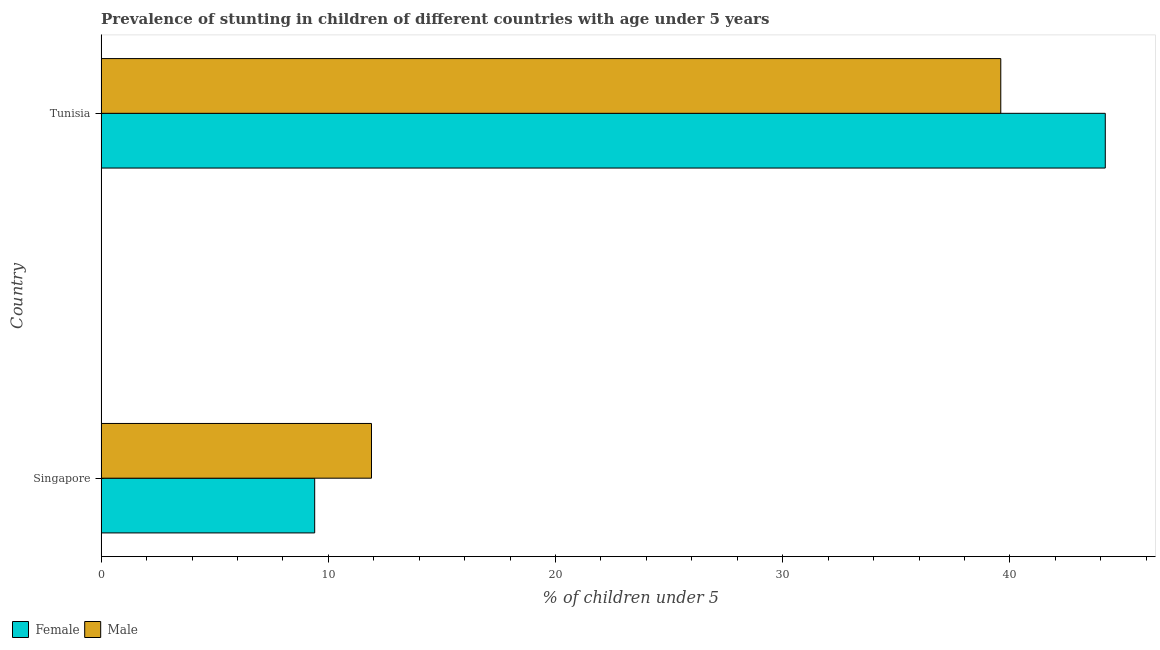Are the number of bars per tick equal to the number of legend labels?
Offer a very short reply. Yes. What is the label of the 1st group of bars from the top?
Keep it short and to the point. Tunisia. In how many cases, is the number of bars for a given country not equal to the number of legend labels?
Offer a terse response. 0. What is the percentage of stunted male children in Singapore?
Give a very brief answer. 11.9. Across all countries, what is the maximum percentage of stunted male children?
Ensure brevity in your answer.  39.6. Across all countries, what is the minimum percentage of stunted male children?
Give a very brief answer. 11.9. In which country was the percentage of stunted female children maximum?
Ensure brevity in your answer.  Tunisia. In which country was the percentage of stunted female children minimum?
Ensure brevity in your answer.  Singapore. What is the total percentage of stunted female children in the graph?
Provide a succinct answer. 53.6. What is the difference between the percentage of stunted female children in Singapore and that in Tunisia?
Your answer should be compact. -34.8. What is the difference between the percentage of stunted female children in Singapore and the percentage of stunted male children in Tunisia?
Provide a short and direct response. -30.2. What is the average percentage of stunted female children per country?
Give a very brief answer. 26.8. What is the difference between the percentage of stunted male children and percentage of stunted female children in Tunisia?
Provide a succinct answer. -4.6. What is the ratio of the percentage of stunted female children in Singapore to that in Tunisia?
Provide a short and direct response. 0.21. Is the percentage of stunted male children in Singapore less than that in Tunisia?
Make the answer very short. Yes. What does the 1st bar from the bottom in Singapore represents?
Provide a short and direct response. Female. How many countries are there in the graph?
Your response must be concise. 2. What is the difference between two consecutive major ticks on the X-axis?
Keep it short and to the point. 10. Are the values on the major ticks of X-axis written in scientific E-notation?
Provide a succinct answer. No. Where does the legend appear in the graph?
Ensure brevity in your answer.  Bottom left. How many legend labels are there?
Keep it short and to the point. 2. What is the title of the graph?
Offer a terse response. Prevalence of stunting in children of different countries with age under 5 years. What is the label or title of the X-axis?
Your response must be concise.  % of children under 5. What is the label or title of the Y-axis?
Your answer should be compact. Country. What is the  % of children under 5 in Female in Singapore?
Your answer should be compact. 9.4. What is the  % of children under 5 of Male in Singapore?
Offer a terse response. 11.9. What is the  % of children under 5 in Female in Tunisia?
Offer a very short reply. 44.2. What is the  % of children under 5 of Male in Tunisia?
Provide a short and direct response. 39.6. Across all countries, what is the maximum  % of children under 5 of Female?
Offer a terse response. 44.2. Across all countries, what is the maximum  % of children under 5 of Male?
Provide a short and direct response. 39.6. Across all countries, what is the minimum  % of children under 5 in Female?
Offer a terse response. 9.4. Across all countries, what is the minimum  % of children under 5 of Male?
Your answer should be compact. 11.9. What is the total  % of children under 5 in Female in the graph?
Keep it short and to the point. 53.6. What is the total  % of children under 5 of Male in the graph?
Provide a succinct answer. 51.5. What is the difference between the  % of children under 5 in Female in Singapore and that in Tunisia?
Your response must be concise. -34.8. What is the difference between the  % of children under 5 of Male in Singapore and that in Tunisia?
Offer a very short reply. -27.7. What is the difference between the  % of children under 5 in Female in Singapore and the  % of children under 5 in Male in Tunisia?
Keep it short and to the point. -30.2. What is the average  % of children under 5 of Female per country?
Your answer should be very brief. 26.8. What is the average  % of children under 5 in Male per country?
Keep it short and to the point. 25.75. What is the difference between the  % of children under 5 in Female and  % of children under 5 in Male in Singapore?
Your answer should be very brief. -2.5. What is the difference between the  % of children under 5 in Female and  % of children under 5 in Male in Tunisia?
Keep it short and to the point. 4.6. What is the ratio of the  % of children under 5 of Female in Singapore to that in Tunisia?
Make the answer very short. 0.21. What is the ratio of the  % of children under 5 of Male in Singapore to that in Tunisia?
Your answer should be compact. 0.3. What is the difference between the highest and the second highest  % of children under 5 of Female?
Provide a succinct answer. 34.8. What is the difference between the highest and the second highest  % of children under 5 in Male?
Your response must be concise. 27.7. What is the difference between the highest and the lowest  % of children under 5 of Female?
Provide a succinct answer. 34.8. What is the difference between the highest and the lowest  % of children under 5 of Male?
Keep it short and to the point. 27.7. 